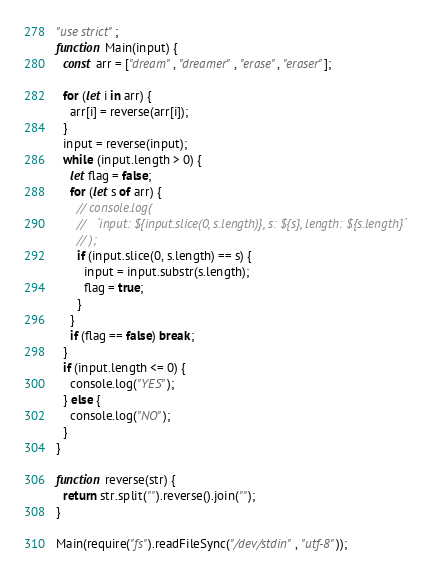Convert code to text. <code><loc_0><loc_0><loc_500><loc_500><_JavaScript_>"use strict";
function Main(input) {
  const arr = ["dream", "dreamer", "erase", "eraser"];

  for (let i in arr) {
    arr[i] = reverse(arr[i]);
  }
  input = reverse(input);
  while (input.length > 0) {
    let flag = false;
    for (let s of arr) {
      // console.log(
      //   `input: ${input.slice(0, s.length)}, s: ${s}, length: ${s.length}`
      // );
      if (input.slice(0, s.length) == s) {
        input = input.substr(s.length);
        flag = true;
      }
    }
    if (flag == false) break;
  }
  if (input.length <= 0) {
    console.log("YES");
  } else {
    console.log("NO");
  }
}

function reverse(str) {
  return str.split("").reverse().join("");
}

Main(require("fs").readFileSync("/dev/stdin", "utf-8"));
</code> 